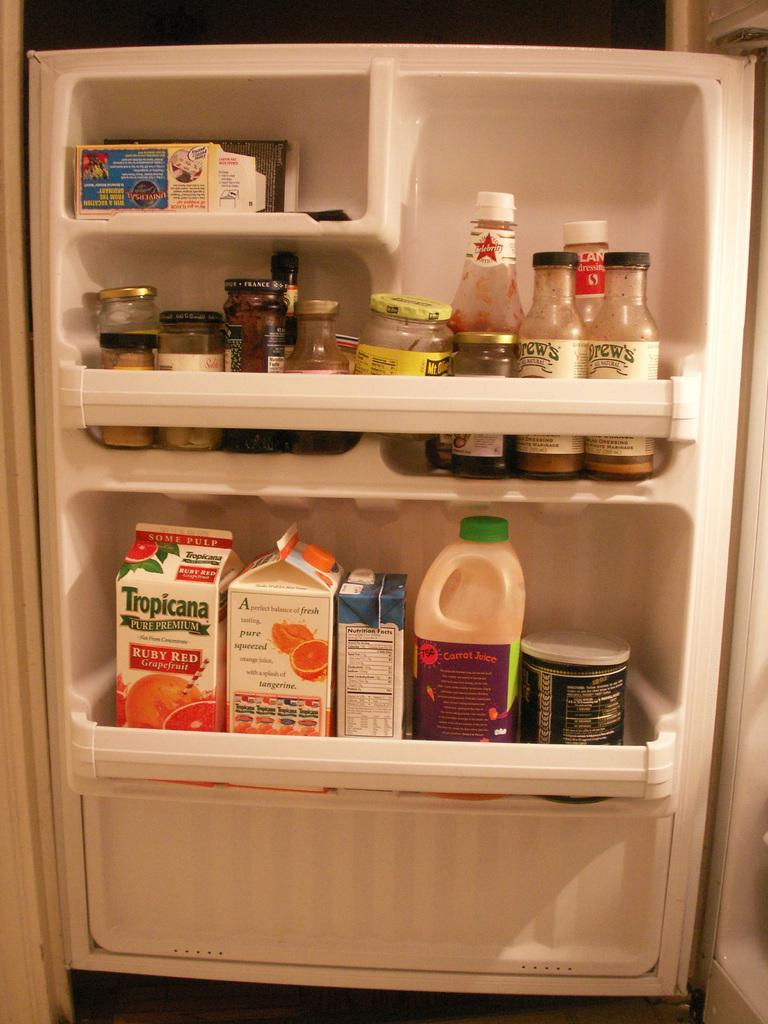What type of appliance is the image depicting? The image is an inner view of a refrigerator. What can be seen inside the refrigerator? There are bottles and fruit juices visible inside the refrigerator. How many quarters are visible inside the refrigerator? There are no quarters visible inside the refrigerator; it contains bottles and fruit juices. What type of animal can be seen inside the refrigerator? There are no animals visible inside the refrigerator; it contains bottles and fruit juices. 